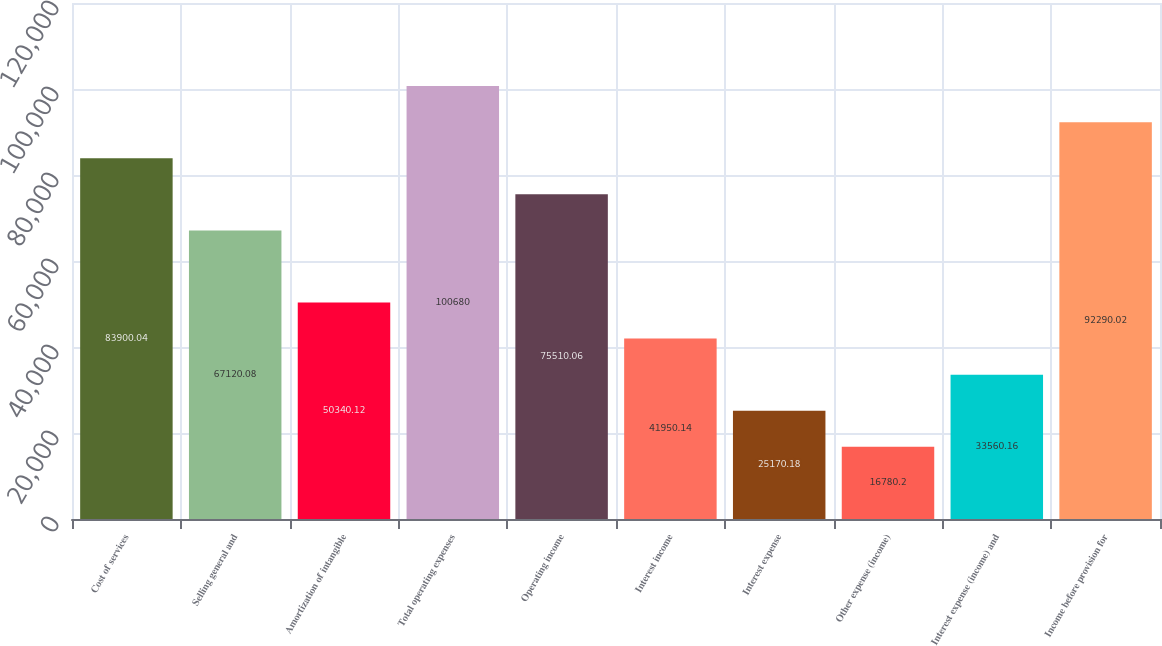Convert chart to OTSL. <chart><loc_0><loc_0><loc_500><loc_500><bar_chart><fcel>Cost of services<fcel>Selling general and<fcel>Amortization of intangible<fcel>Total operating expenses<fcel>Operating income<fcel>Interest income<fcel>Interest expense<fcel>Other expense (income)<fcel>Interest expense (income) and<fcel>Income before provision for<nl><fcel>83900<fcel>67120.1<fcel>50340.1<fcel>100680<fcel>75510.1<fcel>41950.1<fcel>25170.2<fcel>16780.2<fcel>33560.2<fcel>92290<nl></chart> 